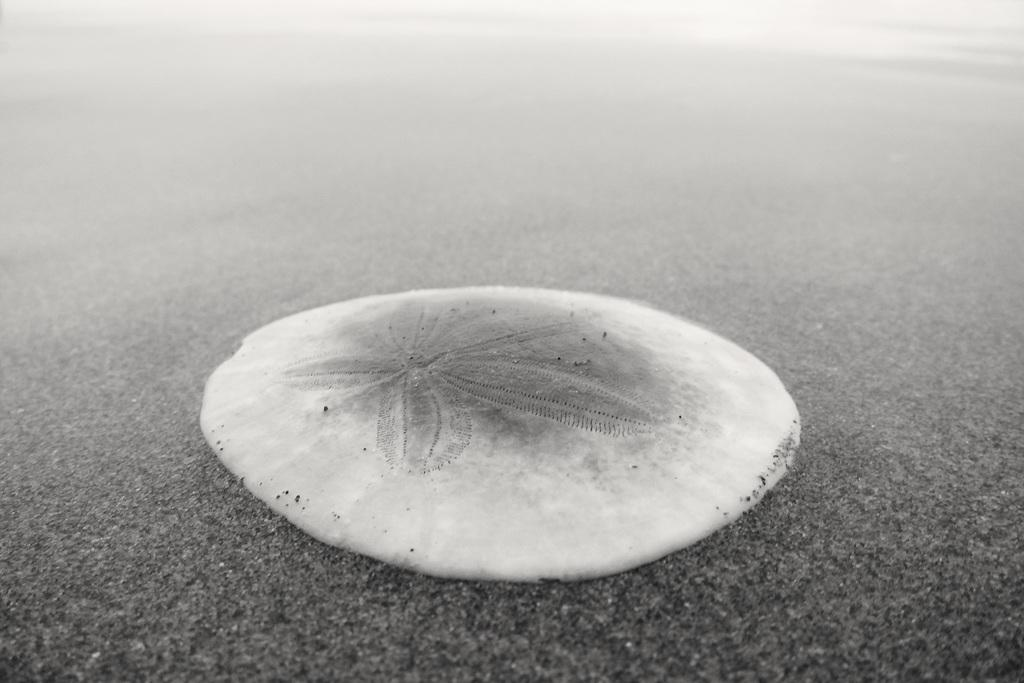What is the color of the shell in the image? The shell in the image is white. Where is the shell located in the image? The shell is visible on the road. How does the queen interact with the crowd in the image? There is no queen or crowd present in the image; it only features a white color shell on the road. 